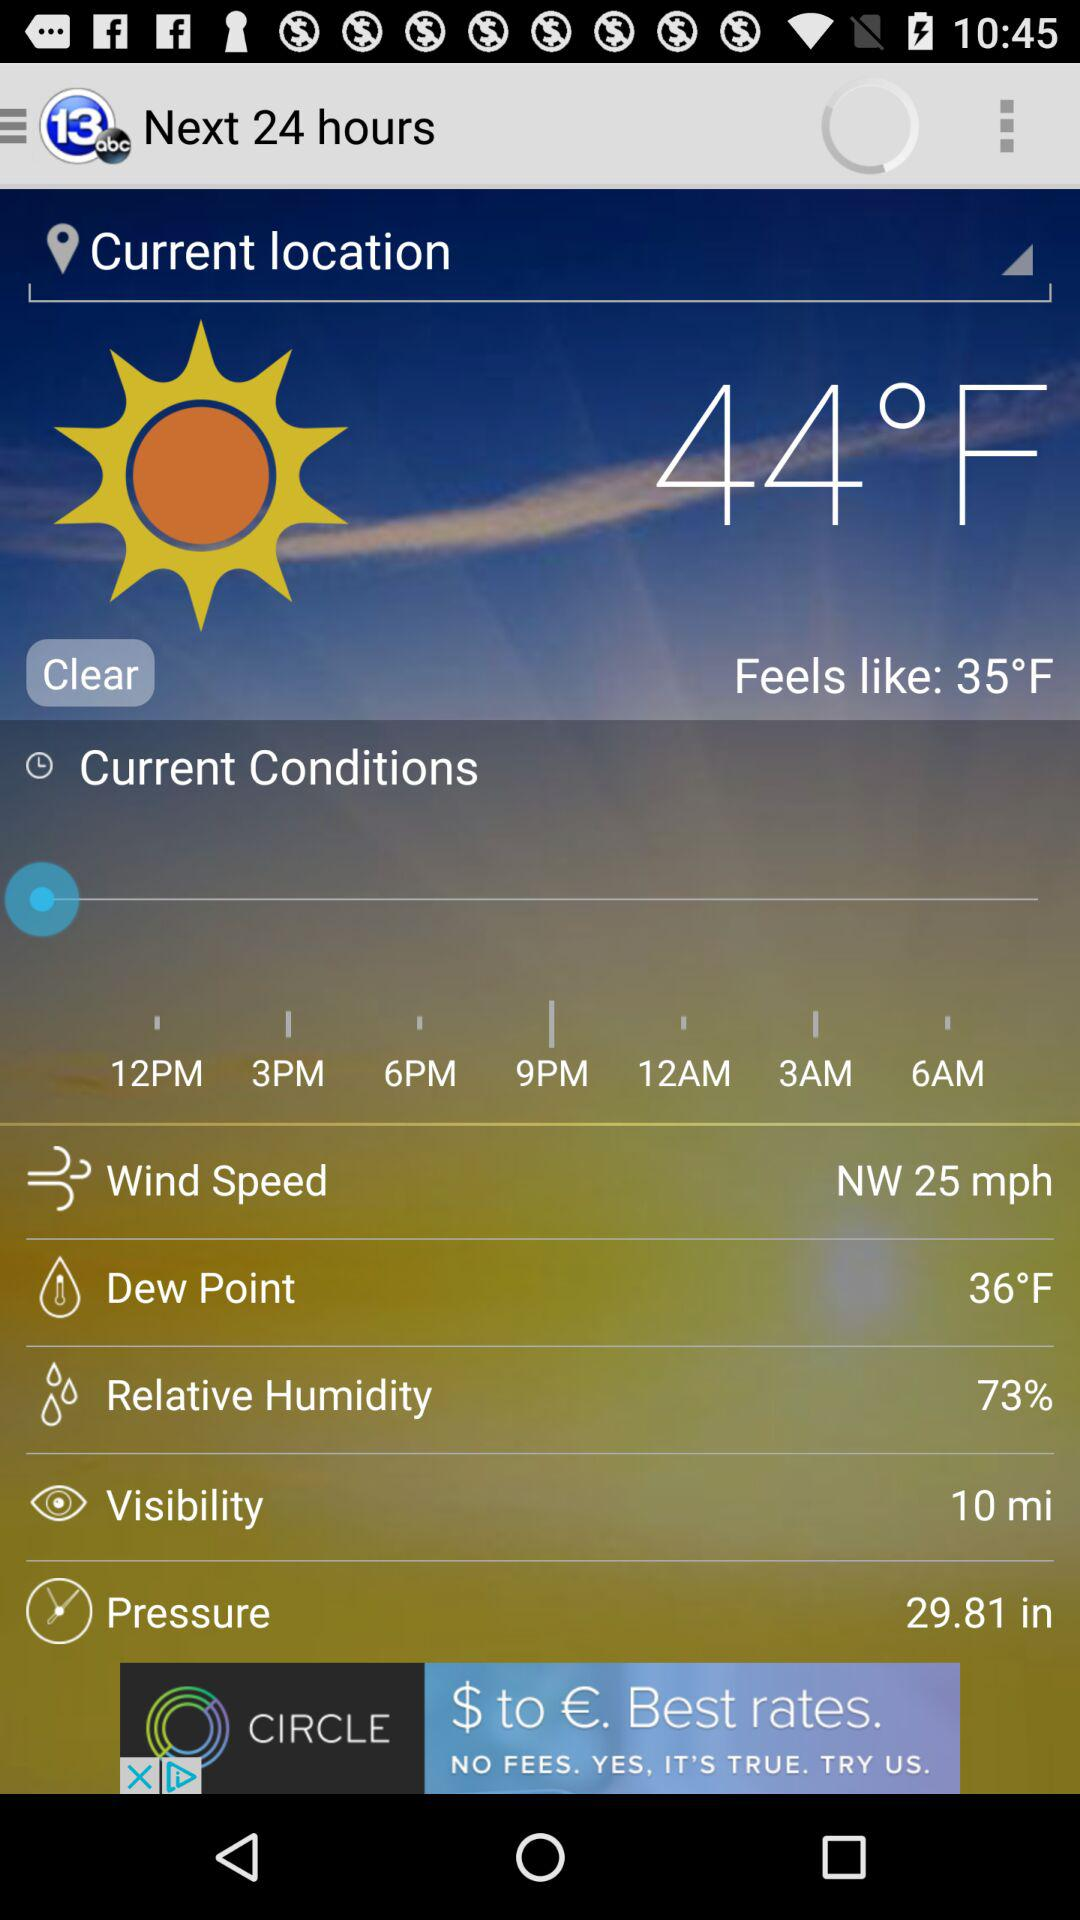What is the visibility? The visibility is 10 miles. 